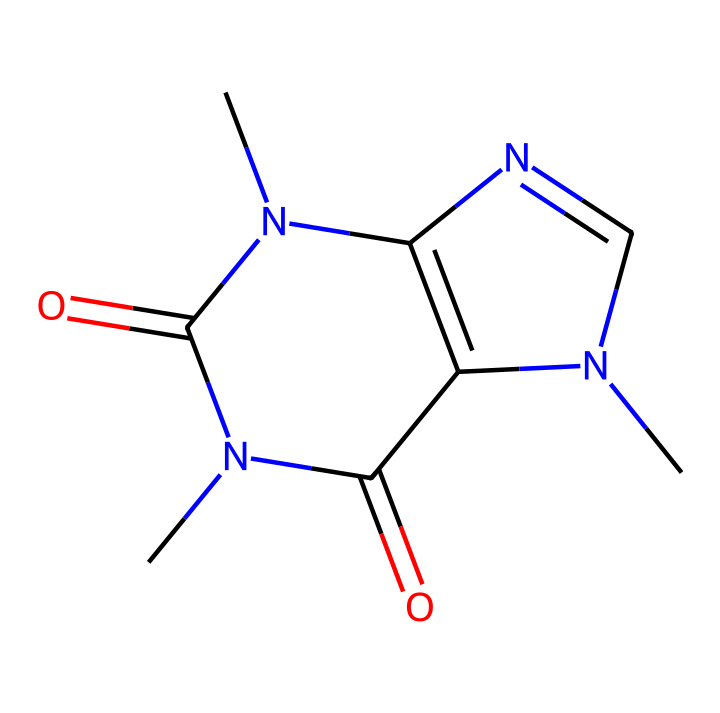How many nitrogen atoms are in the caffeine structure? By examining the SMILES representation, we can identify the nitrogen atoms represented by the letter 'N'. In this structure, there are three instances of 'N', indicating the presence of three nitrogen atoms.
Answer: three What is the molecular formula of caffeine? To find the molecular formula, we can count the number of each type of atom present in the SMILES. There are 8 carbon (C), 10 hydrogen (H), 4 nitrogen (N), and 2 oxygen (O) atoms, leading to the formula C8H10N4O2.
Answer: C8H10N4O2 What type of chemical bonding is predominantly found in caffeine? The caffeine structure contains several types of bonds, but the majority are covalent bonds, which connect the atoms together. This is evident from the defined connections between the atoms throughout the SMILES representation.
Answer: covalent What functional groups are present in the caffeine structure? By analyzing the structure, we can identify functional groups like amides and the carbonyl groups. The presence of the nitrogen atoms indicates amide functional groups, as they are linked with carbonyl oxygens.
Answer: amide, carbonyl How many rings are present in the caffeine molecule? From the given SMILES, the structure exhibits a bicyclic arrangement, indicated by the numerical labels (like 'N1' and 'N2') that denote ring closures. Therefore, there are two interconnected rings in caffeine.
Answer: two What effect does the presence of nitrogen have on caffeine's activity? The nitrogen atoms influence caffeine's psychoactive properties, contributing to its role as a stimulant. Nitrogen is often present in compounds that can act on the nervous system, such as dopamine and neurotransmitters, enhancing its stimulating effects.
Answer: stimulant 